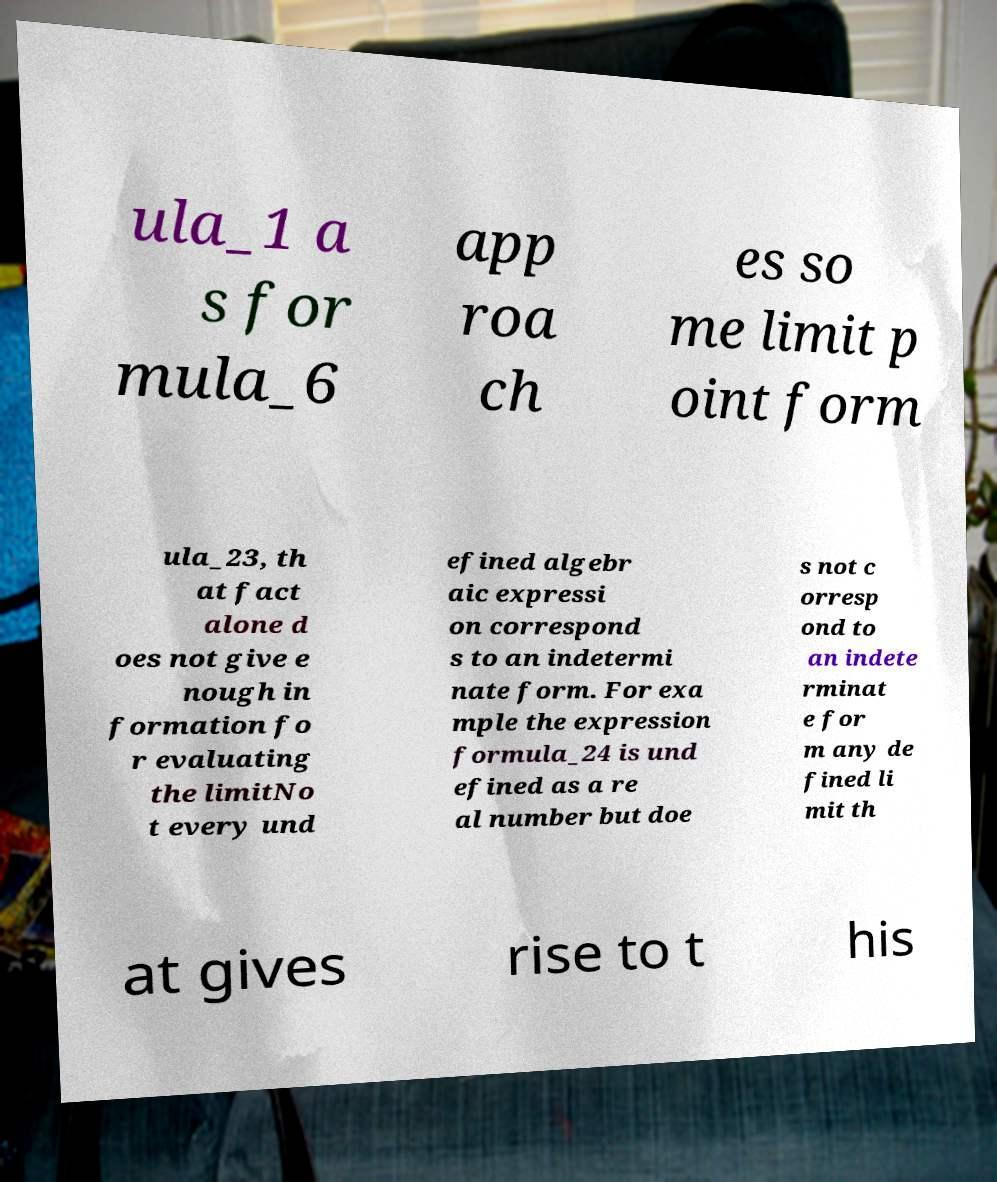Please read and relay the text visible in this image. What does it say? ula_1 a s for mula_6 app roa ch es so me limit p oint form ula_23, th at fact alone d oes not give e nough in formation fo r evaluating the limitNo t every und efined algebr aic expressi on correspond s to an indetermi nate form. For exa mple the expression formula_24 is und efined as a re al number but doe s not c orresp ond to an indete rminat e for m any de fined li mit th at gives rise to t his 